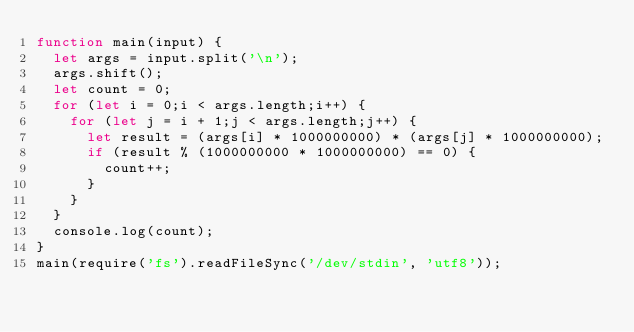Convert code to text. <code><loc_0><loc_0><loc_500><loc_500><_JavaScript_>function main(input) {
  let args = input.split('\n');
  args.shift();
  let count = 0;
  for (let i = 0;i < args.length;i++) {
    for (let j = i + 1;j < args.length;j++) {
      let result = (args[i] * 1000000000) * (args[j] * 1000000000);
      if (result % (1000000000 * 1000000000) == 0) {
    	count++;
      }
    }
  }
  console.log(count);
}
main(require('fs').readFileSync('/dev/stdin', 'utf8'));</code> 